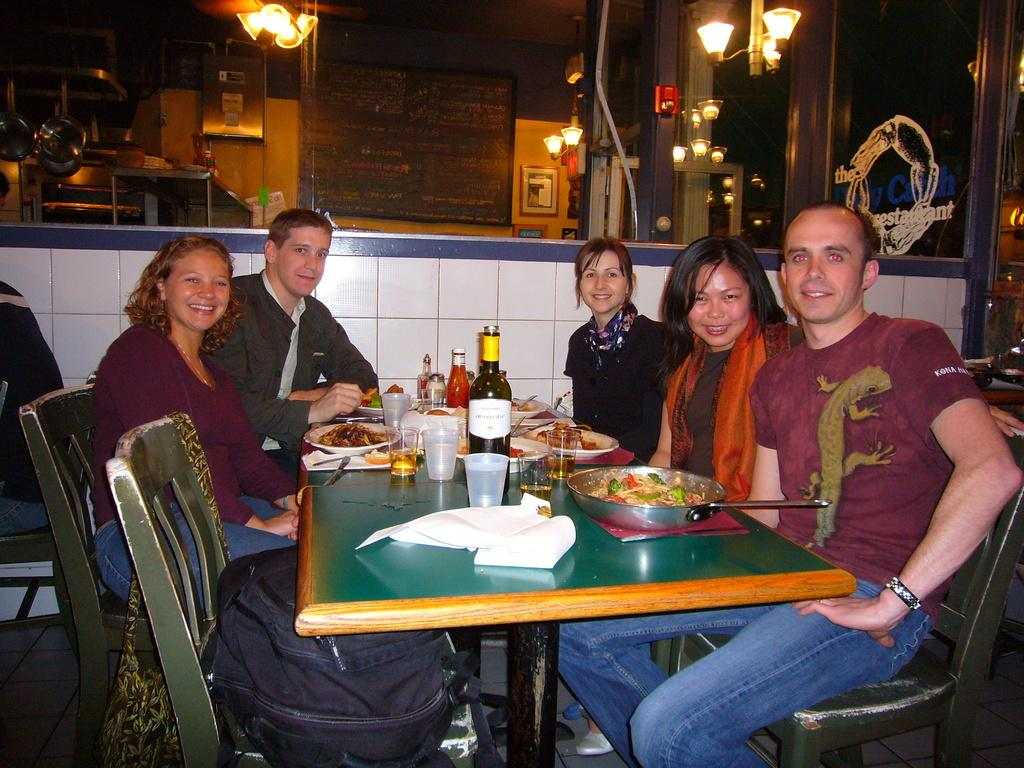How many people are sitting in the chairs in the image? There are five persons sitting on chairs in the image. What items can be seen on the table? There are bottles, glasses, spoons, food, and papers on the table. What can be observed in the background of the image? There are lights, a board, and a wall in the background. What type of birds can be seen flying around the secretary in the image? There is no secretary or birds present in the image. What theory is being discussed by the persons in the image? There is no indication of a theory being discussed in the image. 